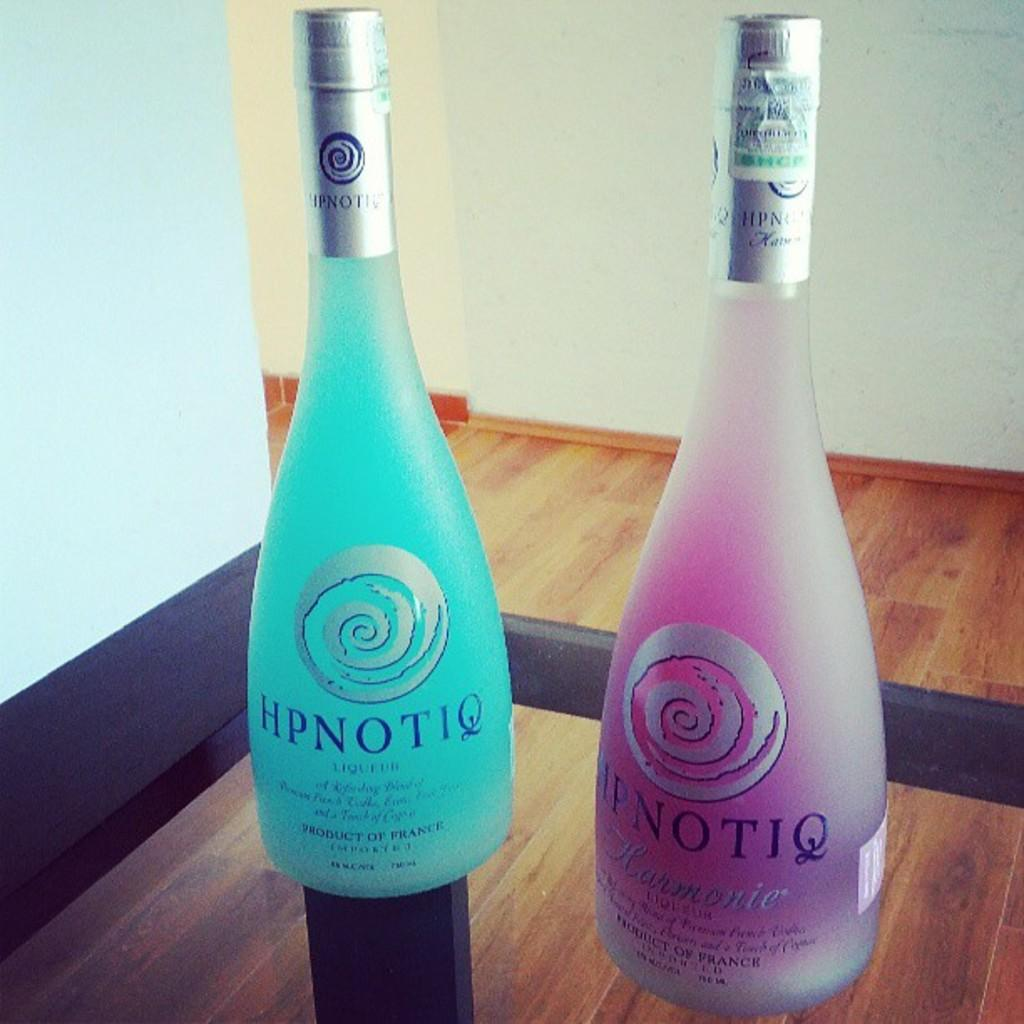<image>
Describe the image concisely. Two bottles of HPNOTIQ sit next to each other in a display. 